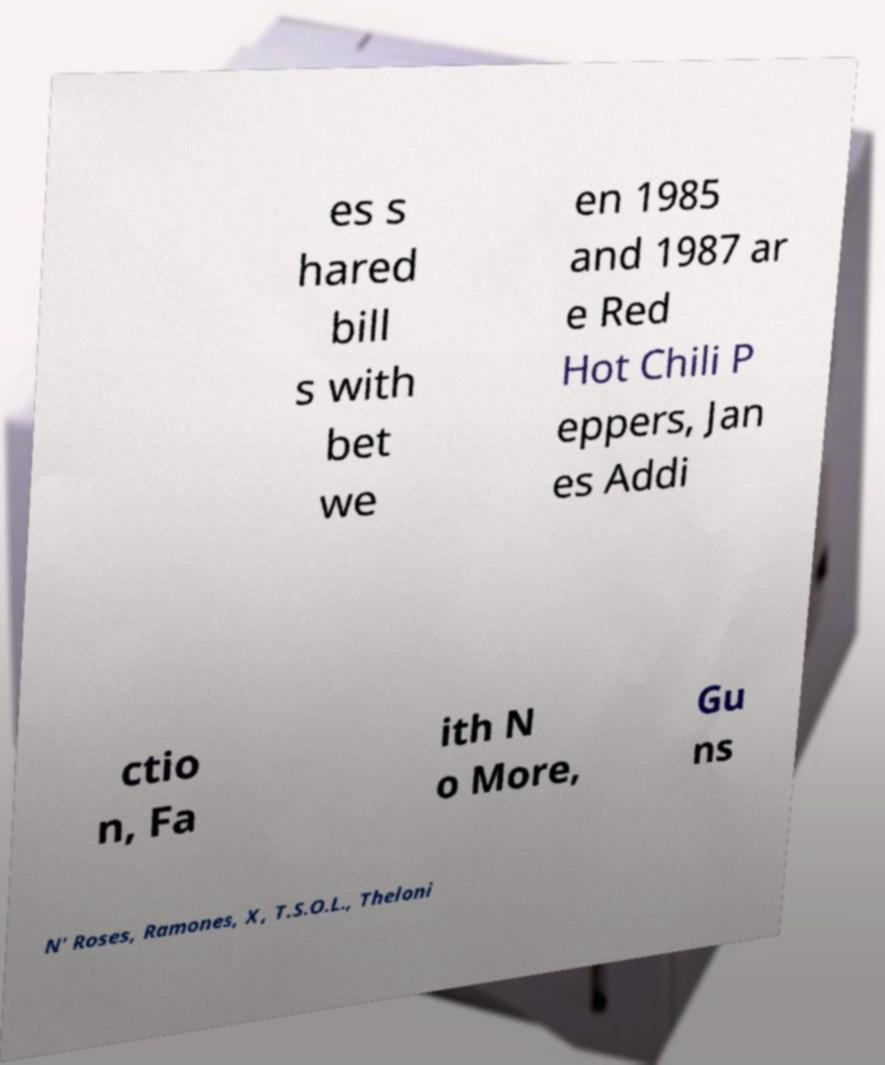Could you assist in decoding the text presented in this image and type it out clearly? es s hared bill s with bet we en 1985 and 1987 ar e Red Hot Chili P eppers, Jan es Addi ctio n, Fa ith N o More, Gu ns N' Roses, Ramones, X, T.S.O.L., Theloni 